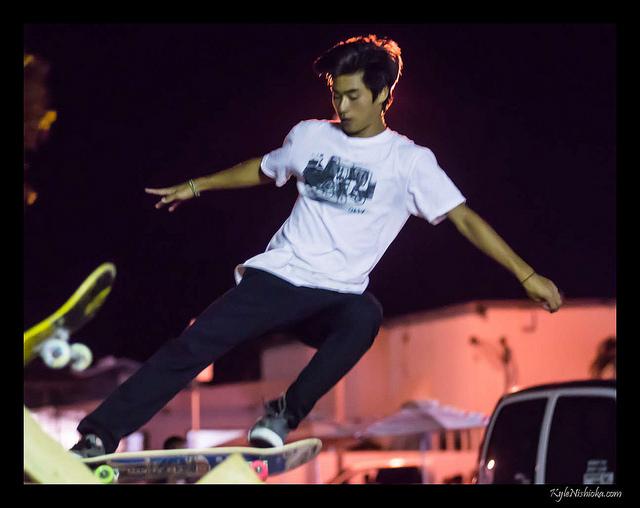Is he holding his skateboard?
Answer briefly. No. Which game are they playing?
Give a very brief answer. Skateboarding. How many wheels are visible?
Answer briefly. 4. Is he riding the skateboard indoors or outdoors?
Write a very short answer. Outdoors. Is it night time?
Answer briefly. Yes. Is this person roller skating?
Write a very short answer. No. 